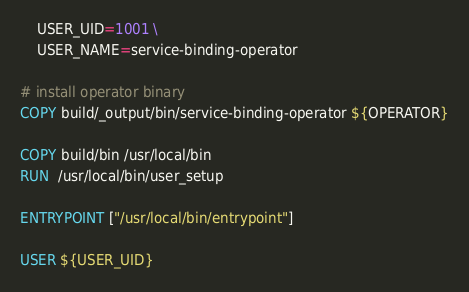<code> <loc_0><loc_0><loc_500><loc_500><_Dockerfile_>    USER_UID=1001 \
    USER_NAME=service-binding-operator

# install operator binary
COPY build/_output/bin/service-binding-operator ${OPERATOR}

COPY build/bin /usr/local/bin
RUN  /usr/local/bin/user_setup

ENTRYPOINT ["/usr/local/bin/entrypoint"]

USER ${USER_UID}
</code> 